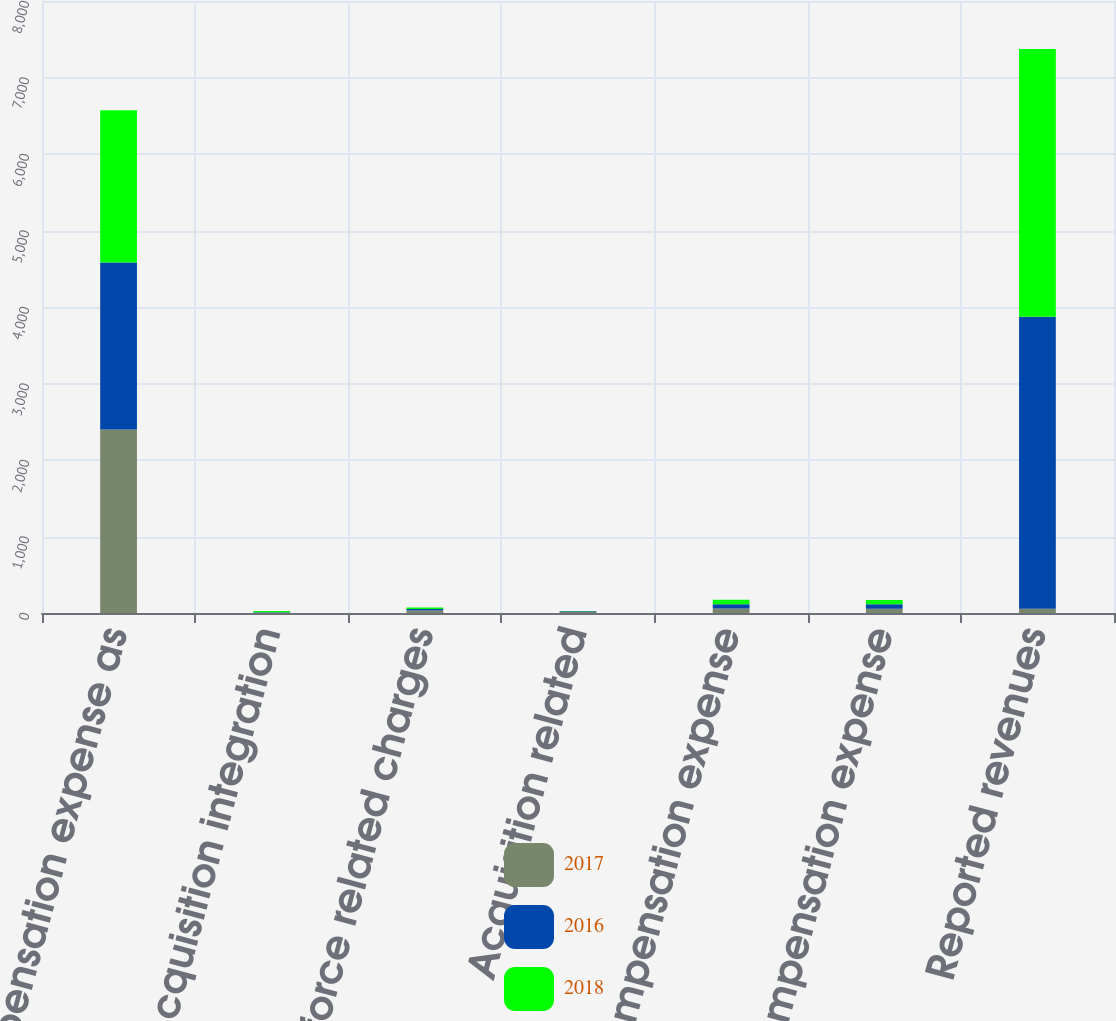Convert chart. <chart><loc_0><loc_0><loc_500><loc_500><stacked_bar_chart><ecel><fcel>Compensation expense as<fcel>Acquisition integration<fcel>Workforce related charges<fcel>Acquisition related<fcel>Reported compensation expense<fcel>Adjusted compensation expense<fcel>Reported revenues<nl><fcel>2017<fcel>2398.1<fcel>2.5<fcel>32.3<fcel>14.2<fcel>57.6<fcel>56.6<fcel>57.1<nl><fcel>2016<fcel>2182.9<fcel>7.6<fcel>21.4<fcel>9.1<fcel>58<fcel>57.1<fcel>3815.1<nl><fcel>2018<fcel>1990.4<fcel>16.9<fcel>17.5<fcel>3.7<fcel>58.3<fcel>57.1<fcel>3501.6<nl></chart> 